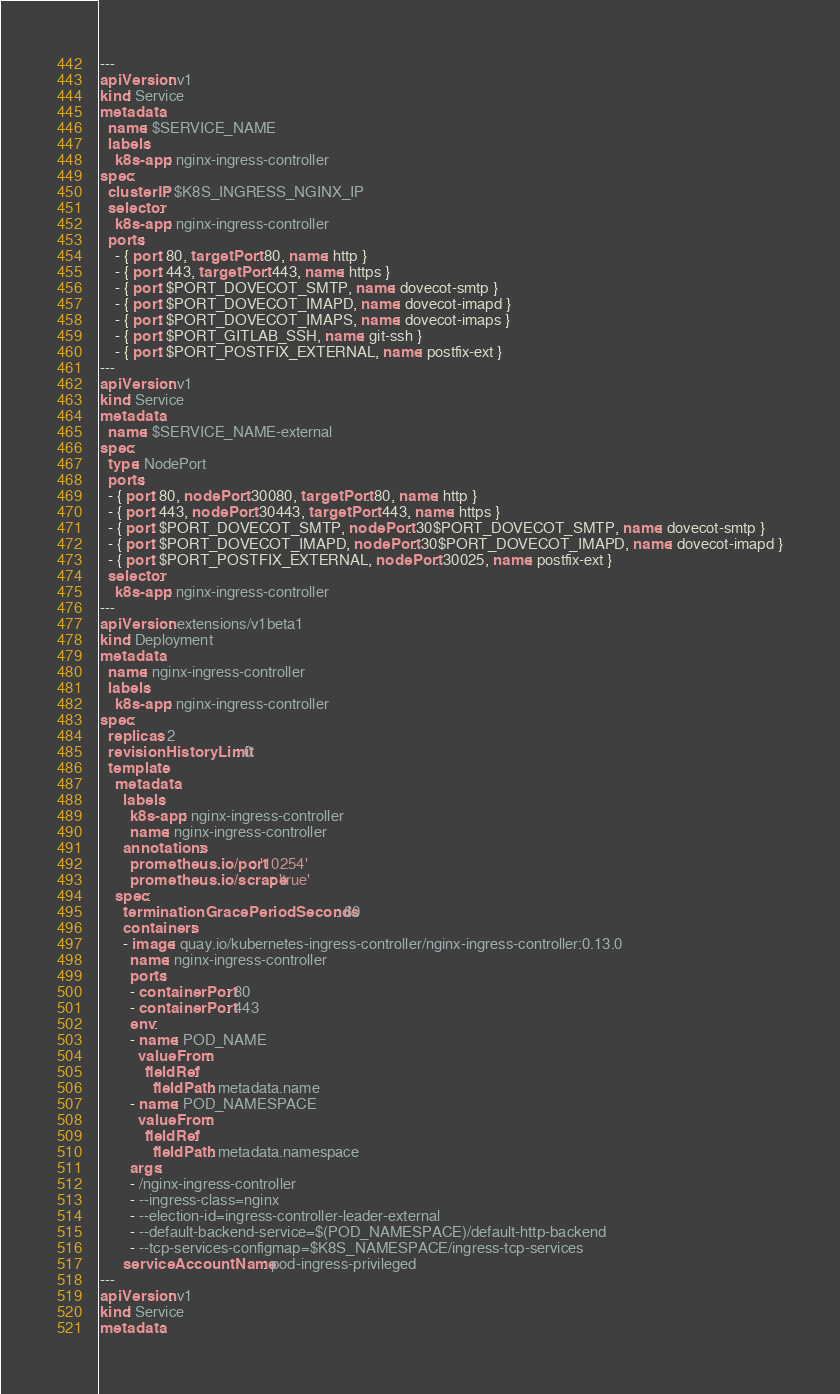Convert code to text. <code><loc_0><loc_0><loc_500><loc_500><_YAML_>---
apiVersion: v1
kind: Service
metadata:
  name: $SERVICE_NAME
  labels:
    k8s-app: nginx-ingress-controller
spec:
  clusterIP: $K8S_INGRESS_NGINX_IP
  selector:
    k8s-app: nginx-ingress-controller
  ports:
    - { port: 80, targetPort: 80, name: http }
    - { port: 443, targetPort: 443, name: https }
    - { port: $PORT_DOVECOT_SMTP, name: dovecot-smtp }
    - { port: $PORT_DOVECOT_IMAPD, name: dovecot-imapd }
    - { port: $PORT_DOVECOT_IMAPS, name: dovecot-imaps }
    - { port: $PORT_GITLAB_SSH, name: git-ssh }
    - { port: $PORT_POSTFIX_EXTERNAL, name: postfix-ext }
---
apiVersion: v1
kind: Service
metadata:
  name: $SERVICE_NAME-external
spec:
  type: NodePort
  ports:
  - { port: 80, nodePort: 30080, targetPort: 80, name: http }
  - { port: 443, nodePort: 30443, targetPort: 443, name: https }
  - { port: $PORT_DOVECOT_SMTP, nodePort: 30$PORT_DOVECOT_SMTP, name: dovecot-smtp }
  - { port: $PORT_DOVECOT_IMAPD, nodePort: 30$PORT_DOVECOT_IMAPD, name: dovecot-imapd }
  - { port: $PORT_POSTFIX_EXTERNAL, nodePort: 30025, name: postfix-ext }
  selector:
    k8s-app: nginx-ingress-controller
---
apiVersion: extensions/v1beta1
kind: Deployment
metadata:
  name: nginx-ingress-controller
  labels:
    k8s-app: nginx-ingress-controller
spec:
  replicas: 2
  revisionHistoryLimit: 0
  template:
    metadata:
      labels:
        k8s-app: nginx-ingress-controller
        name: nginx-ingress-controller
      annotations:
        prometheus.io/port: '10254'
        prometheus.io/scrape: 'true'
    spec:
      terminationGracePeriodSeconds: 60
      containers:
      - image: quay.io/kubernetes-ingress-controller/nginx-ingress-controller:0.13.0
        name: nginx-ingress-controller
        ports:
        - containerPort: 80
        - containerPort: 443
        env:
        - name: POD_NAME
          valueFrom:
            fieldRef:
              fieldPath: metadata.name
        - name: POD_NAMESPACE
          valueFrom:
            fieldRef:
              fieldPath: metadata.namespace
        args:
        - /nginx-ingress-controller
        - --ingress-class=nginx
        - --election-id=ingress-controller-leader-external
        - --default-backend-service=$(POD_NAMESPACE)/default-http-backend
        - --tcp-services-configmap=$K8S_NAMESPACE/ingress-tcp-services
      serviceAccountName: pod-ingress-privileged
---
apiVersion: v1
kind: Service
metadata:</code> 